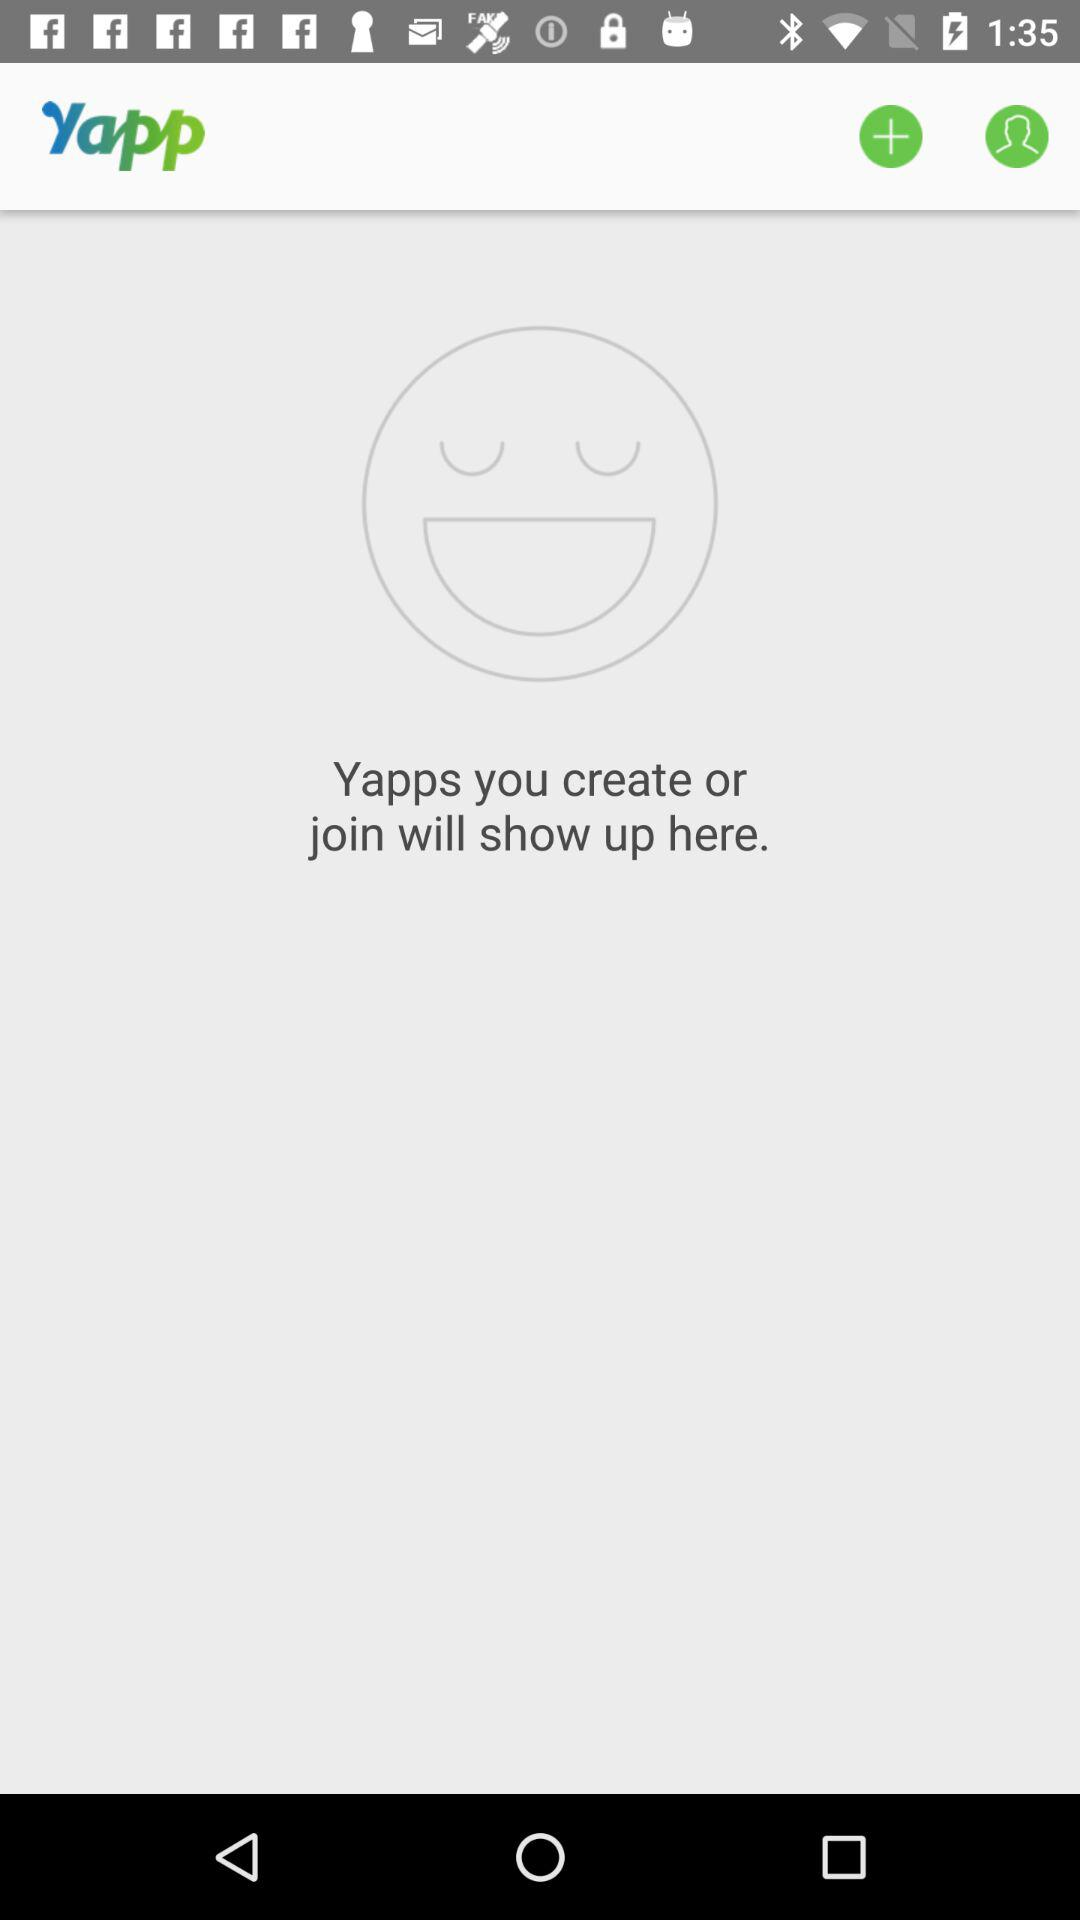What is the application name? The application name is "yapp". 